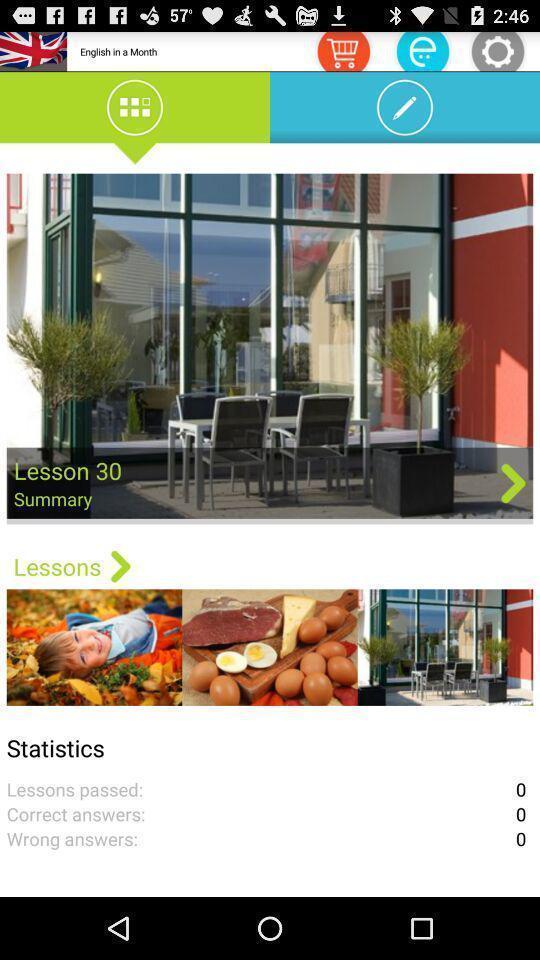What can you discern from this picture? Statistics of a lesson summery. 